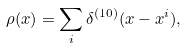<formula> <loc_0><loc_0><loc_500><loc_500>\rho ( x ) = \sum _ { i } \delta ^ { ( 1 0 ) } ( x - x ^ { i } ) ,</formula> 